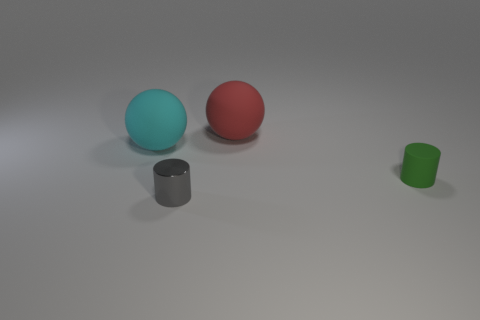What is the shape of the object that is in front of the cylinder behind the gray metallic cylinder?
Provide a short and direct response. Cylinder. Is there a tiny blue thing?
Provide a succinct answer. No. There is a red thing that is behind the object to the left of the tiny gray thing; what number of tiny gray shiny cylinders are left of it?
Provide a short and direct response. 1. There is a gray thing; does it have the same shape as the big matte object that is on the right side of the big cyan ball?
Make the answer very short. No. Are there more rubber spheres than tiny rubber cylinders?
Offer a very short reply. Yes. Is there any other thing that has the same size as the cyan ball?
Ensure brevity in your answer.  Yes. Is the shape of the big rubber object that is in front of the red matte thing the same as  the red thing?
Your response must be concise. Yes. Are there more objects that are left of the red sphere than gray metal cylinders?
Provide a succinct answer. Yes. There is a big rubber object that is behind the ball that is left of the gray metallic object; what is its color?
Your answer should be compact. Red. How many tiny blue shiny balls are there?
Give a very brief answer. 0. 